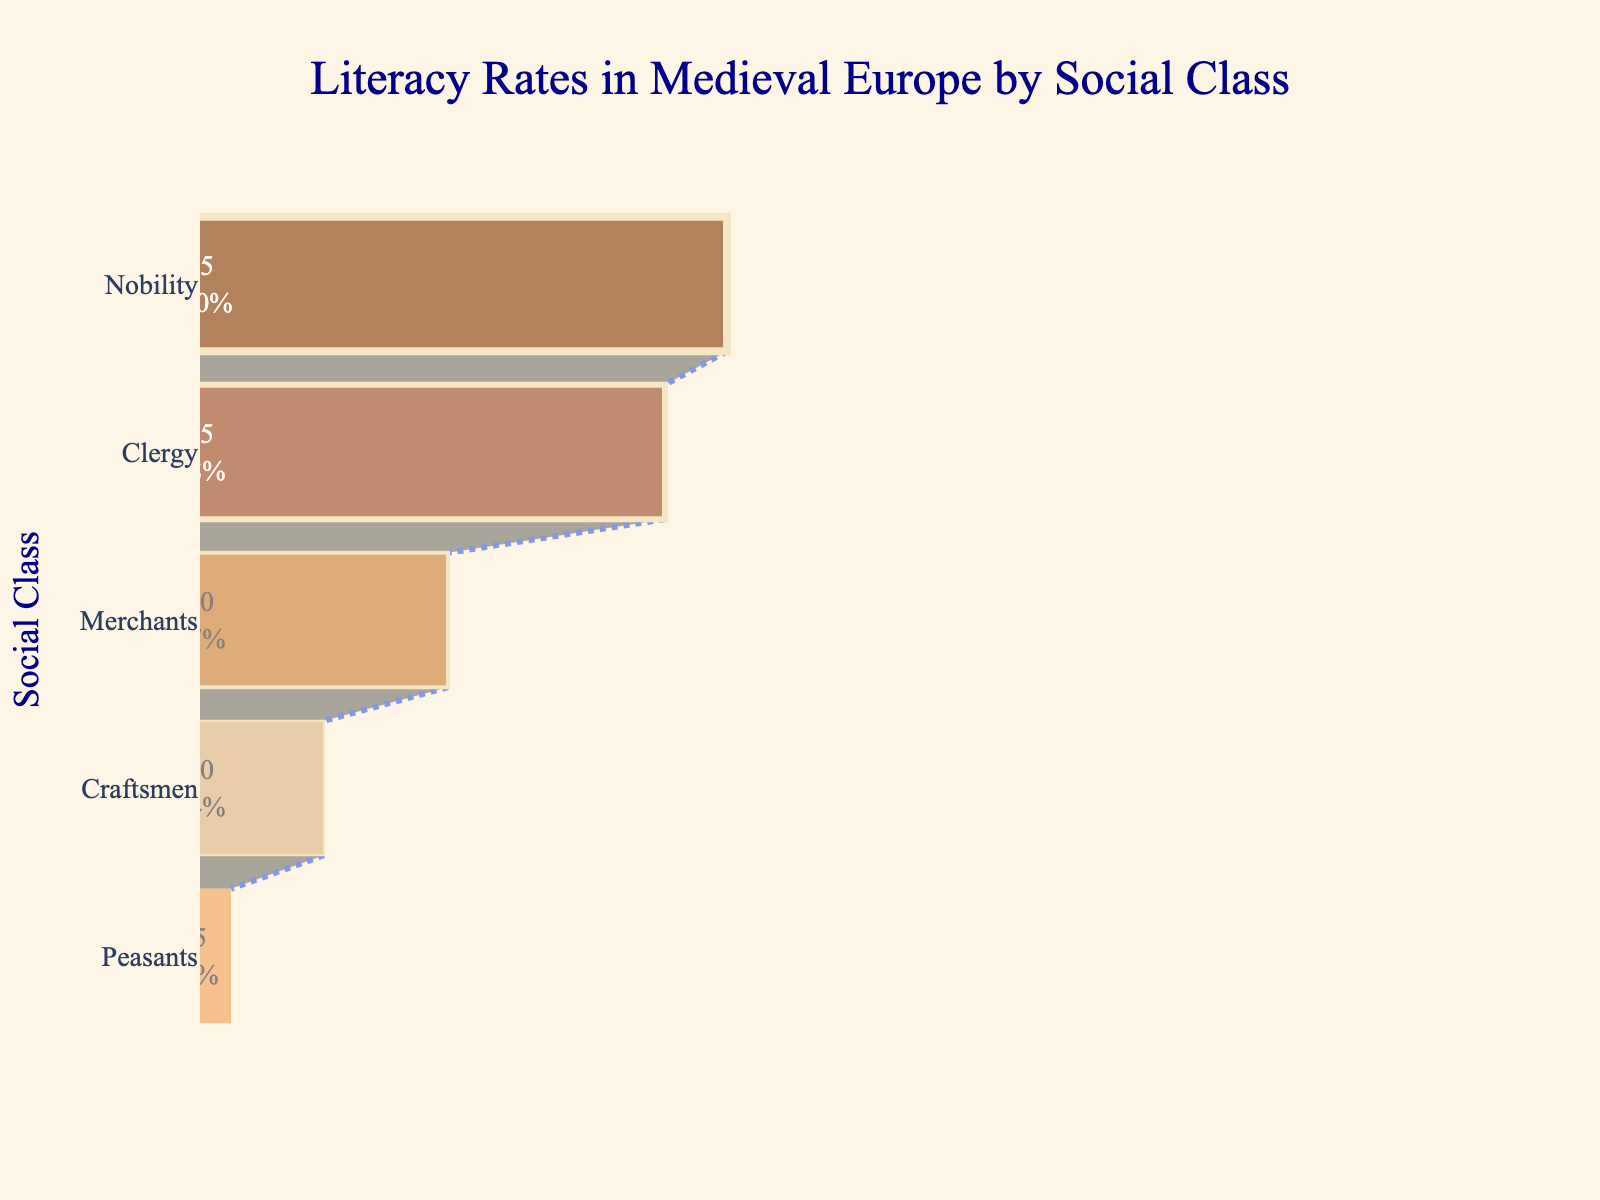What's the title of the chart? The title of the chart can be found at the top, which typically describes the overall subject of the figure.
Answer: Literacy Rates in Medieval Europe by Social Class Which social class has the highest literacy rate? By looking at the largest section of the funnel chart, which is usually at the top, you can identify the social class with the highest literacy rate.
Answer: Nobility What is the literacy rate for the Peasants social class? The literacy rate can be found at the bottom of the funnel chart where the Peasants are listed, as each section corresponds to a different social class.
Answer: 5% What's the difference in literacy rates between Nobility and Merchants? To find the difference, identify the literacy rates of Nobility and Merchants from the chart, then subtract the Merchants' rate from the Nobility's rate: 85 - 40 = 45
Answer: 45 What percentage of the total literacy rate does the Clergy represent initially? To find this, locate the literacy rate for Clergy, and then note the percentage information displayed inside the section for Clergy. It shows the percentage compared to the initial group value.
Answer: Approximately 23% Compare the literacy rates of Craftsmen and Peasants. Which is higher and by how much? Identify the literacy rates of both classes (Craftsmen: 20%, Peasants: 5%), then subtract the Peasants' rate from the Craftsmen's rate: 20 - 5 = 15. Thus, Craftsmen have a higher literacy rate by 15%.
Answer: Craftsmen have a higher rate by 15% Which segment of the funnel chart indicates the transition from a moderate to a high literacy rate? Observing the sizes of the sections, focus on the transition between Merchants (40%) to Clergy (75%), indicating a significant increase and boundary from moderate to high literacy rates.
Answer: Between Merchants and Clergy What's the average literacy rate among all the social classes listed? Add all literacy rates (85 + 75 + 40 + 20 + 5 = 225) and divide by the number of social classes (5), which calculates to an average of 45%.
Answer: 45% Which social class shows a literacy rate closest to the overall average? First, compute the average literacy rate as explained before (45%). Then, compare each class's rate to find the one nearest to this value. The Merchants' rate (40%) is closest to the average (45%).
Answer: Merchants 